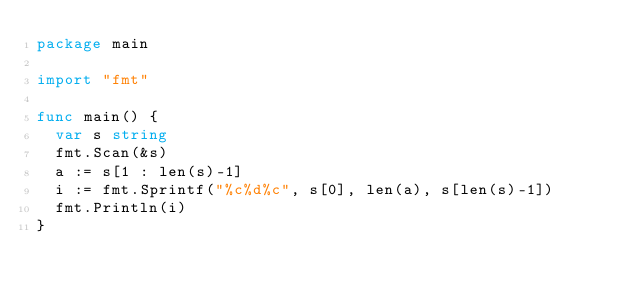Convert code to text. <code><loc_0><loc_0><loc_500><loc_500><_Go_>package main
 
import "fmt"
 
func main() {
	var s string
	fmt.Scan(&s)
	a := s[1 : len(s)-1]
	i := fmt.Sprintf("%c%d%c", s[0], len(a), s[len(s)-1])
	fmt.Println(i)
}</code> 